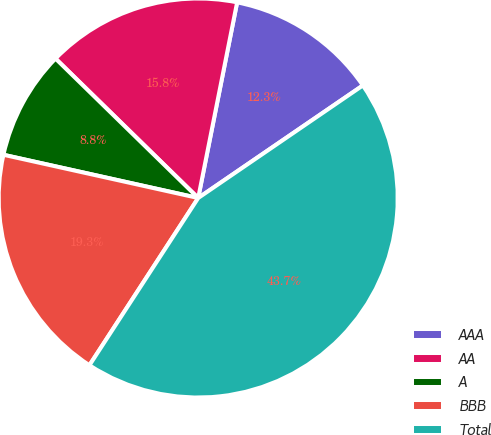<chart> <loc_0><loc_0><loc_500><loc_500><pie_chart><fcel>AAA<fcel>AA<fcel>A<fcel>BBB<fcel>Total<nl><fcel>12.33%<fcel>15.81%<fcel>8.84%<fcel>19.3%<fcel>43.72%<nl></chart> 